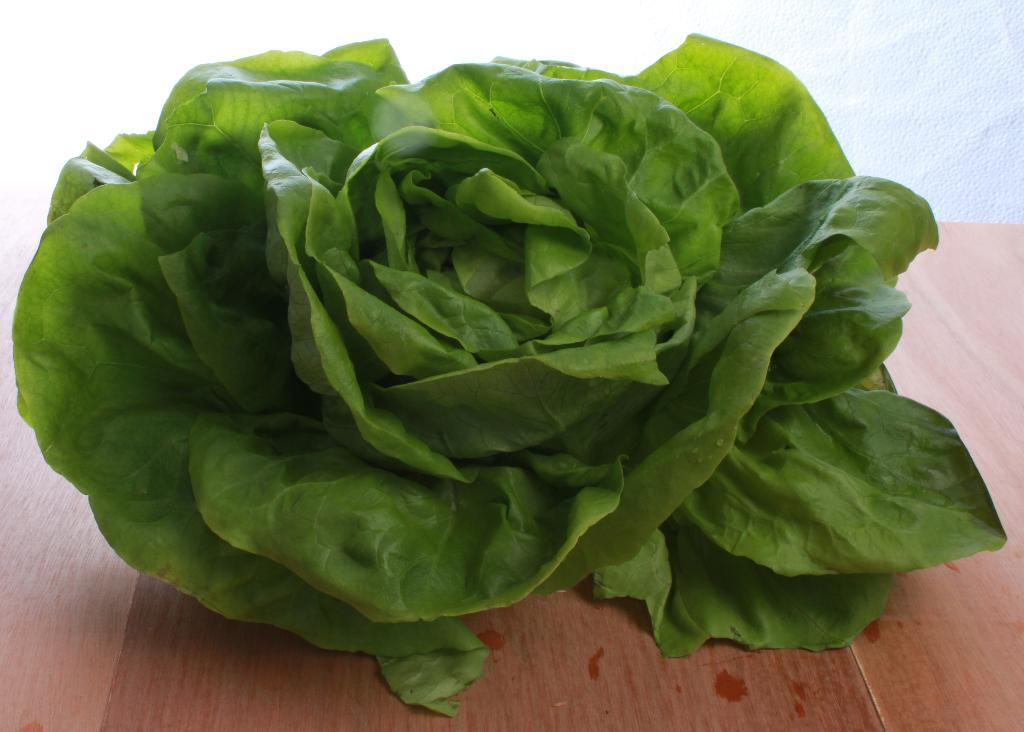What is present on the wooden surface in the image? There are leaves on a wooden surface in the image. What color is the background of the image? The background of the image is white in color. What type of kite can be seen flying in the image? There is no kite present in the image; it only features leaves on a wooden surface and a white background. How many needles are visible in the image? There are no needles present in the image. 